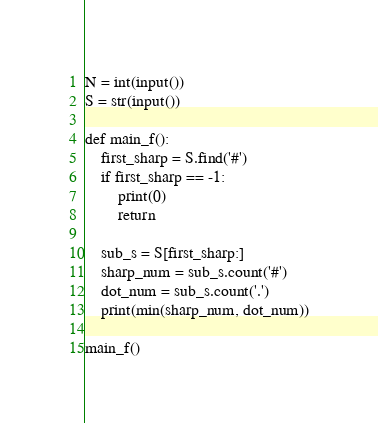<code> <loc_0><loc_0><loc_500><loc_500><_Python_>N = int(input())
S = str(input())

def main_f():
    first_sharp = S.find('#')
    if first_sharp == -1:
        print(0)
        return
    
    sub_s = S[first_sharp:]
    sharp_num = sub_s.count('#')
    dot_num = sub_s.count('.')
    print(min(sharp_num, dot_num))

main_f()</code> 